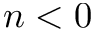<formula> <loc_0><loc_0><loc_500><loc_500>n < 0</formula> 